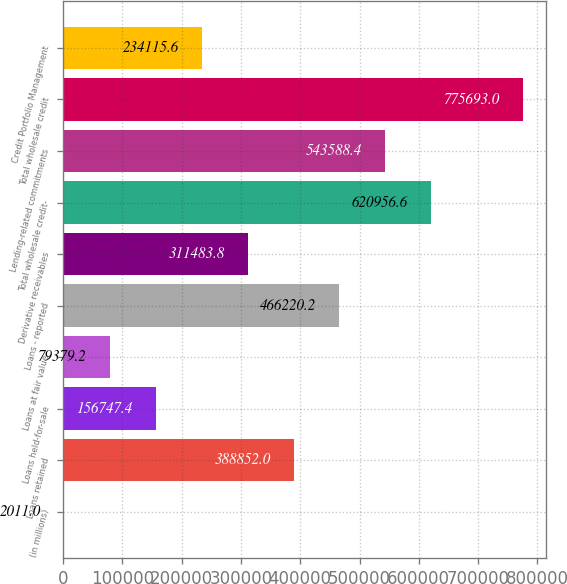Convert chart. <chart><loc_0><loc_0><loc_500><loc_500><bar_chart><fcel>(in millions)<fcel>Loans retained<fcel>Loans held-for-sale<fcel>Loans at fair value<fcel>Loans - reported<fcel>Derivative receivables<fcel>Total wholesale credit-<fcel>Lending-related commitments<fcel>Total wholesale credit<fcel>Credit Portfolio Management<nl><fcel>2011<fcel>388852<fcel>156747<fcel>79379.2<fcel>466220<fcel>311484<fcel>620957<fcel>543588<fcel>775693<fcel>234116<nl></chart> 